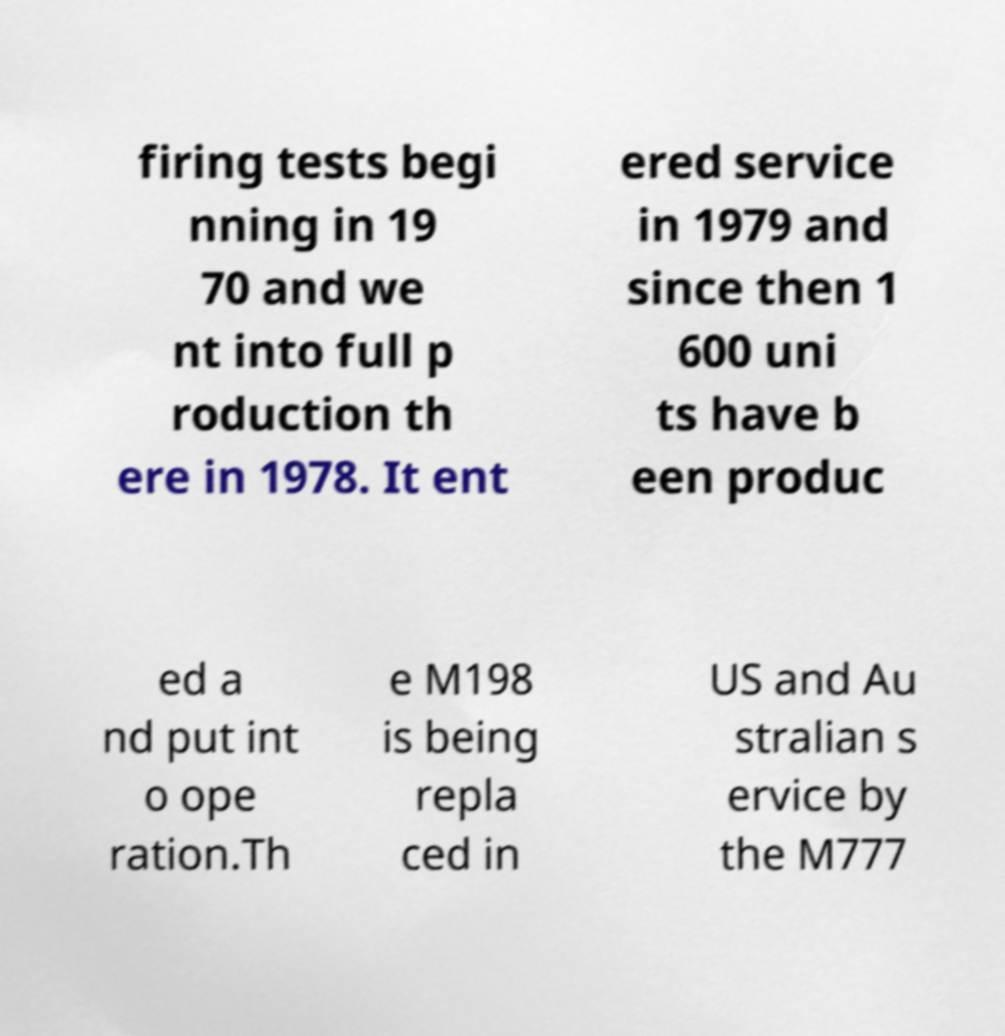There's text embedded in this image that I need extracted. Can you transcribe it verbatim? firing tests begi nning in 19 70 and we nt into full p roduction th ere in 1978. It ent ered service in 1979 and since then 1 600 uni ts have b een produc ed a nd put int o ope ration.Th e M198 is being repla ced in US and Au stralian s ervice by the M777 